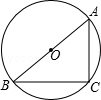First perform reasoning, then finally select the question from the choices in the following format: Answer: xxx.
Question: If in the given figure, the chord AB passes through the center O of circle O, and point C is positioned on the circle, where angle BAC equals 52.0 degrees, what is the measure of angle ABC?
Choices:
A: 26°
B: 38°
C: 30°
D: 32° Answer: since circle O chord AB passes through the center O, so AB is the diameter. therefore, angle C = 90°, therefore, angle ABC = 90° - angle BAC = 90° - 52° = 38°. Therefore, the answer is B.
Answer:B 